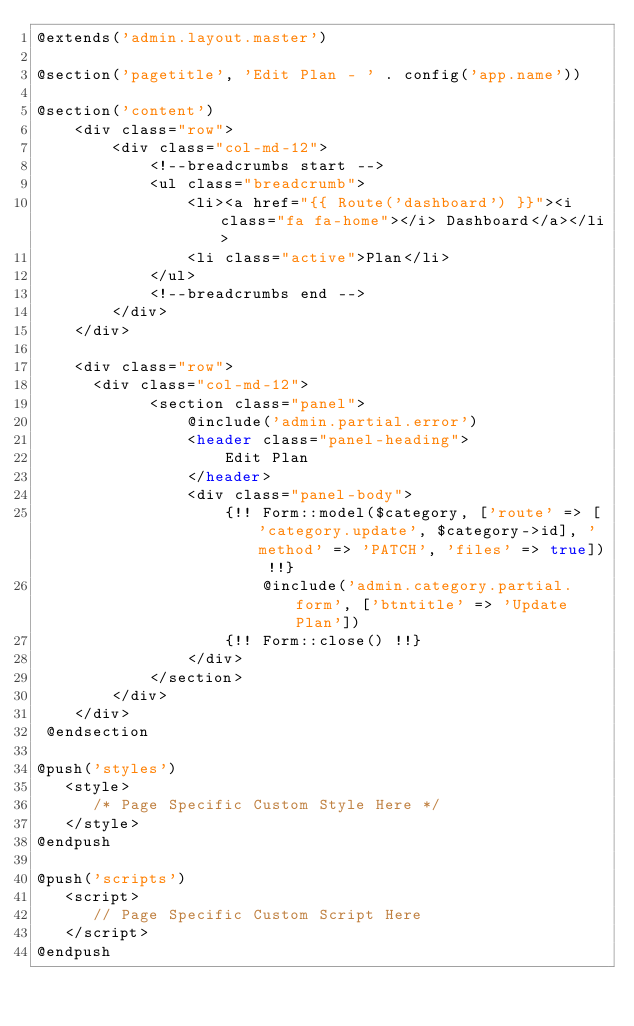<code> <loc_0><loc_0><loc_500><loc_500><_PHP_>@extends('admin.layout.master')

@section('pagetitle', 'Edit Plan - ' . config('app.name'))

@section('content')
    <div class="row">
        <div class="col-md-12">
            <!--breadcrumbs start -->
            <ul class="breadcrumb">
                <li><a href="{{ Route('dashboard') }}"><i class="fa fa-home"></i> Dashboard</a></li>
                <li class="active">Plan</li>
            </ul>
            <!--breadcrumbs end -->
        </div>
    </div>
    
    <div class="row">
      <div class="col-md-12">
            <section class="panel">
                @include('admin.partial.error')
                <header class="panel-heading">
                    Edit Plan
                </header>
                <div class="panel-body">
                    {!! Form::model($category, ['route' => ['category.update', $category->id], 'method' => 'PATCH', 'files' => true]) !!}
                        @include('admin.category.partial.form', ['btntitle' => 'Update Plan'])
                    {!! Form::close() !!}
                </div>
            </section>
        </div>
    </div>
 @endsection

@push('styles')
   <style>
      /* Page Specific Custom Style Here */
   </style>
@endpush

@push('scripts')
   <script>
      // Page Specific Custom Script Here 
   </script>
@endpush</code> 